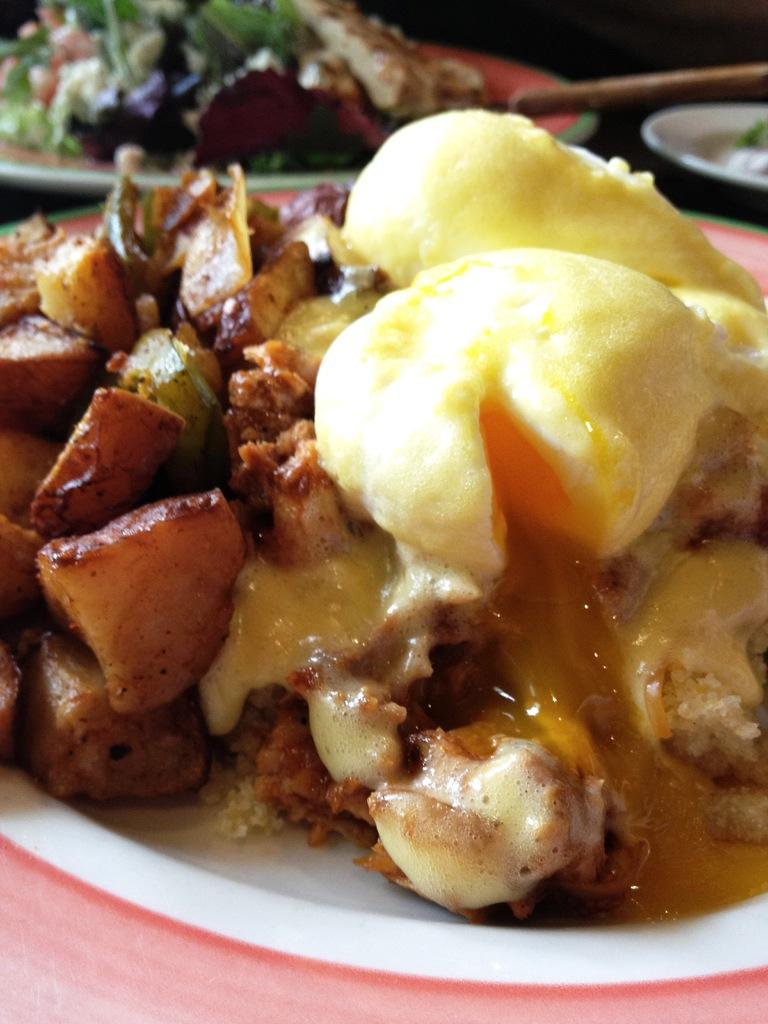What type of food can be seen in the image? There is food in the image, but the specific type is not mentioned. What are the plates used for in the image? The plates are likely used for serving or eating the food in the image. What is the stick on a surface in the image used for? The purpose of the stick on a surface in the image is not clear from the provided facts. What type of lettuce is growing in the box in the image? There is no box or lettuce present in the image. 